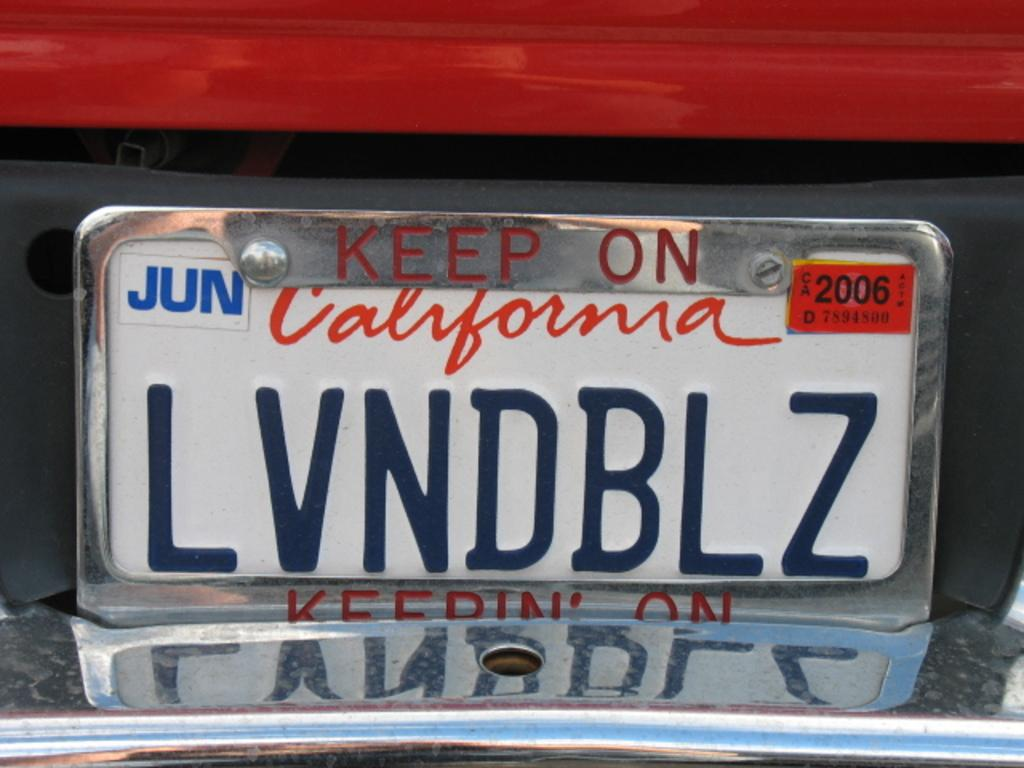<image>
Offer a succinct explanation of the picture presented. a red car with the license plate lvndblz 